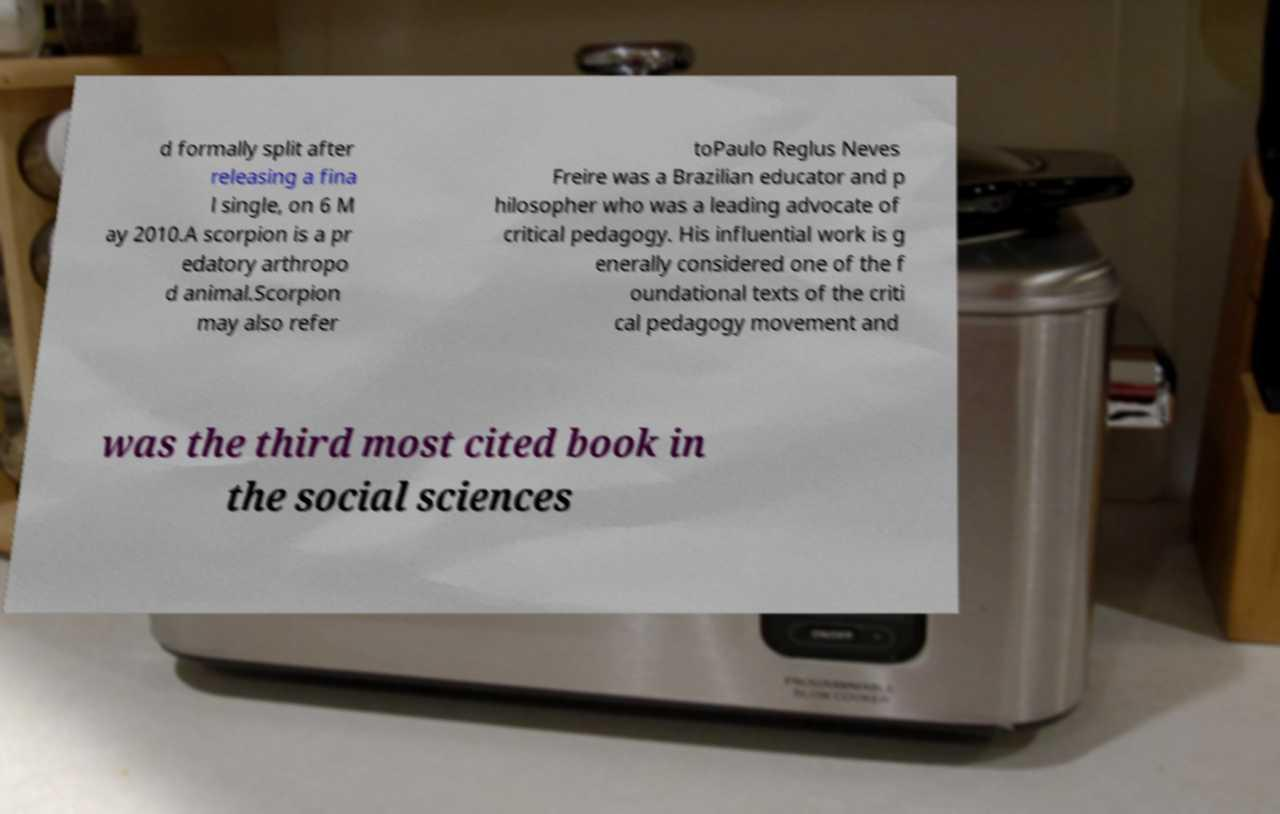Please read and relay the text visible in this image. What does it say? d formally split after releasing a fina l single, on 6 M ay 2010.A scorpion is a pr edatory arthropo d animal.Scorpion may also refer toPaulo Reglus Neves Freire was a Brazilian educator and p hilosopher who was a leading advocate of critical pedagogy. His influential work is g enerally considered one of the f oundational texts of the criti cal pedagogy movement and was the third most cited book in the social sciences 